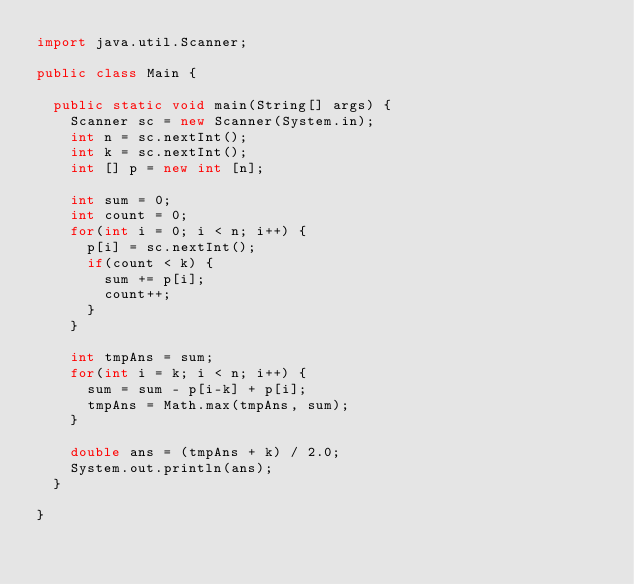<code> <loc_0><loc_0><loc_500><loc_500><_Java_>import java.util.Scanner;

public class Main {

	public static void main(String[] args) {
		Scanner sc = new Scanner(System.in);
		int n = sc.nextInt();
		int k = sc.nextInt();
		int [] p = new int [n];

		int sum = 0;
		int count = 0;
		for(int i = 0; i < n; i++) {
			p[i] = sc.nextInt();
			if(count < k) {
				sum += p[i];
				count++;
			}
		}

		int tmpAns = sum;
		for(int i = k; i < n; i++) {
			sum = sum - p[i-k] + p[i];
			tmpAns = Math.max(tmpAns, sum);
		}

		double ans = (tmpAns + k) / 2.0;
		System.out.println(ans);
	}

}
</code> 